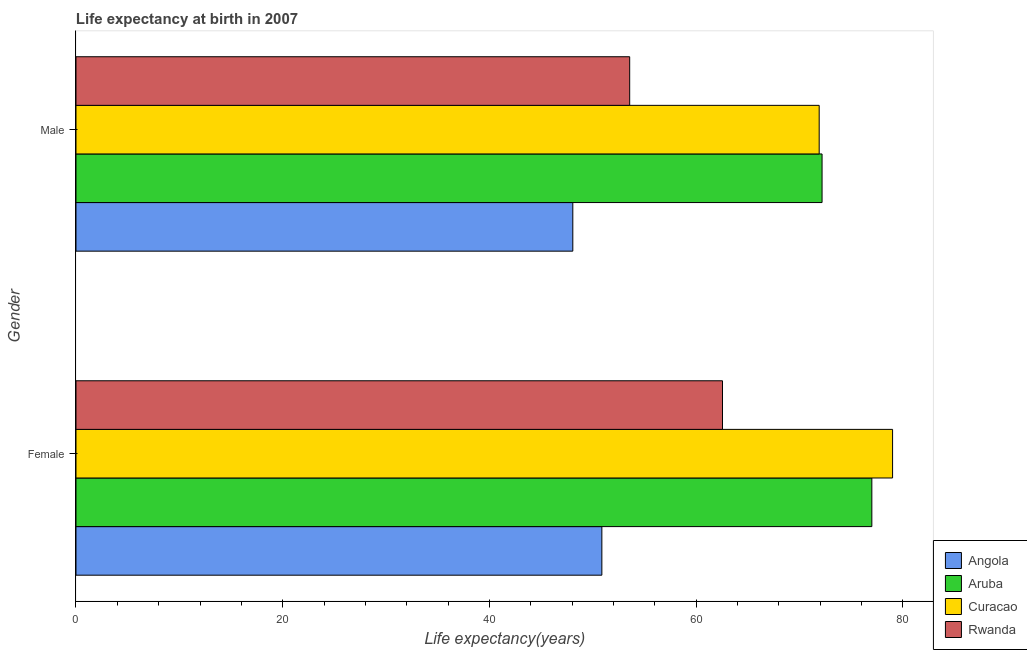How many different coloured bars are there?
Provide a succinct answer. 4. Are the number of bars on each tick of the Y-axis equal?
Your answer should be compact. Yes. How many bars are there on the 1st tick from the bottom?
Make the answer very short. 4. What is the life expectancy(male) in Angola?
Provide a short and direct response. 48.06. Across all countries, what is the maximum life expectancy(male)?
Your response must be concise. 72.18. Across all countries, what is the minimum life expectancy(female)?
Provide a short and direct response. 50.88. In which country was the life expectancy(male) maximum?
Offer a terse response. Aruba. In which country was the life expectancy(male) minimum?
Ensure brevity in your answer.  Angola. What is the total life expectancy(female) in the graph?
Keep it short and to the point. 269.41. What is the difference between the life expectancy(male) in Curacao and that in Rwanda?
Your response must be concise. 18.33. What is the difference between the life expectancy(female) in Curacao and the life expectancy(male) in Angola?
Provide a succinct answer. 30.94. What is the average life expectancy(male) per country?
Give a very brief answer. 61.43. What is the difference between the life expectancy(female) and life expectancy(male) in Angola?
Ensure brevity in your answer.  2.81. In how many countries, is the life expectancy(female) greater than 8 years?
Your response must be concise. 4. What is the ratio of the life expectancy(male) in Rwanda to that in Angola?
Offer a very short reply. 1.11. Is the life expectancy(male) in Angola less than that in Rwanda?
Keep it short and to the point. Yes. In how many countries, is the life expectancy(female) greater than the average life expectancy(female) taken over all countries?
Give a very brief answer. 2. What does the 3rd bar from the top in Female represents?
Ensure brevity in your answer.  Aruba. What does the 4th bar from the bottom in Female represents?
Your response must be concise. Rwanda. How many bars are there?
Keep it short and to the point. 8. How many countries are there in the graph?
Offer a very short reply. 4. What is the difference between two consecutive major ticks on the X-axis?
Provide a succinct answer. 20. Does the graph contain any zero values?
Offer a terse response. No. How are the legend labels stacked?
Your answer should be very brief. Vertical. What is the title of the graph?
Make the answer very short. Life expectancy at birth in 2007. Does "Iceland" appear as one of the legend labels in the graph?
Offer a terse response. No. What is the label or title of the X-axis?
Provide a succinct answer. Life expectancy(years). What is the label or title of the Y-axis?
Keep it short and to the point. Gender. What is the Life expectancy(years) of Angola in Female?
Your response must be concise. 50.88. What is the Life expectancy(years) in Aruba in Female?
Your answer should be very brief. 76.99. What is the Life expectancy(years) in Curacao in Female?
Provide a short and direct response. 79. What is the Life expectancy(years) in Rwanda in Female?
Ensure brevity in your answer.  62.55. What is the Life expectancy(years) in Angola in Male?
Offer a terse response. 48.06. What is the Life expectancy(years) of Aruba in Male?
Your response must be concise. 72.18. What is the Life expectancy(years) of Curacao in Male?
Your answer should be compact. 71.9. What is the Life expectancy(years) in Rwanda in Male?
Provide a succinct answer. 53.57. Across all Gender, what is the maximum Life expectancy(years) in Angola?
Make the answer very short. 50.88. Across all Gender, what is the maximum Life expectancy(years) of Aruba?
Provide a succinct answer. 76.99. Across all Gender, what is the maximum Life expectancy(years) of Curacao?
Provide a short and direct response. 79. Across all Gender, what is the maximum Life expectancy(years) of Rwanda?
Provide a succinct answer. 62.55. Across all Gender, what is the minimum Life expectancy(years) of Angola?
Make the answer very short. 48.06. Across all Gender, what is the minimum Life expectancy(years) of Aruba?
Keep it short and to the point. 72.18. Across all Gender, what is the minimum Life expectancy(years) of Curacao?
Give a very brief answer. 71.9. Across all Gender, what is the minimum Life expectancy(years) in Rwanda?
Provide a succinct answer. 53.57. What is the total Life expectancy(years) of Angola in the graph?
Keep it short and to the point. 98.94. What is the total Life expectancy(years) in Aruba in the graph?
Keep it short and to the point. 149.17. What is the total Life expectancy(years) in Curacao in the graph?
Your answer should be compact. 150.9. What is the total Life expectancy(years) in Rwanda in the graph?
Provide a short and direct response. 116.11. What is the difference between the Life expectancy(years) in Angola in Female and that in Male?
Provide a short and direct response. 2.81. What is the difference between the Life expectancy(years) in Aruba in Female and that in Male?
Keep it short and to the point. 4.82. What is the difference between the Life expectancy(years) of Curacao in Female and that in Male?
Keep it short and to the point. 7.1. What is the difference between the Life expectancy(years) in Rwanda in Female and that in Male?
Ensure brevity in your answer.  8.98. What is the difference between the Life expectancy(years) in Angola in Female and the Life expectancy(years) in Aruba in Male?
Give a very brief answer. -21.3. What is the difference between the Life expectancy(years) of Angola in Female and the Life expectancy(years) of Curacao in Male?
Provide a short and direct response. -21.02. What is the difference between the Life expectancy(years) in Angola in Female and the Life expectancy(years) in Rwanda in Male?
Your answer should be very brief. -2.69. What is the difference between the Life expectancy(years) in Aruba in Female and the Life expectancy(years) in Curacao in Male?
Give a very brief answer. 5.09. What is the difference between the Life expectancy(years) in Aruba in Female and the Life expectancy(years) in Rwanda in Male?
Offer a very short reply. 23.43. What is the difference between the Life expectancy(years) of Curacao in Female and the Life expectancy(years) of Rwanda in Male?
Offer a terse response. 25.43. What is the average Life expectancy(years) of Angola per Gender?
Make the answer very short. 49.47. What is the average Life expectancy(years) of Aruba per Gender?
Provide a short and direct response. 74.59. What is the average Life expectancy(years) of Curacao per Gender?
Give a very brief answer. 75.45. What is the average Life expectancy(years) of Rwanda per Gender?
Offer a terse response. 58.06. What is the difference between the Life expectancy(years) in Angola and Life expectancy(years) in Aruba in Female?
Make the answer very short. -26.12. What is the difference between the Life expectancy(years) of Angola and Life expectancy(years) of Curacao in Female?
Make the answer very short. -28.12. What is the difference between the Life expectancy(years) in Angola and Life expectancy(years) in Rwanda in Female?
Your response must be concise. -11.67. What is the difference between the Life expectancy(years) in Aruba and Life expectancy(years) in Curacao in Female?
Your answer should be compact. -2.01. What is the difference between the Life expectancy(years) in Aruba and Life expectancy(years) in Rwanda in Female?
Provide a succinct answer. 14.45. What is the difference between the Life expectancy(years) in Curacao and Life expectancy(years) in Rwanda in Female?
Your answer should be very brief. 16.45. What is the difference between the Life expectancy(years) of Angola and Life expectancy(years) of Aruba in Male?
Keep it short and to the point. -24.11. What is the difference between the Life expectancy(years) of Angola and Life expectancy(years) of Curacao in Male?
Your response must be concise. -23.84. What is the difference between the Life expectancy(years) in Angola and Life expectancy(years) in Rwanda in Male?
Ensure brevity in your answer.  -5.5. What is the difference between the Life expectancy(years) of Aruba and Life expectancy(years) of Curacao in Male?
Keep it short and to the point. 0.28. What is the difference between the Life expectancy(years) of Aruba and Life expectancy(years) of Rwanda in Male?
Ensure brevity in your answer.  18.61. What is the difference between the Life expectancy(years) in Curacao and Life expectancy(years) in Rwanda in Male?
Give a very brief answer. 18.33. What is the ratio of the Life expectancy(years) in Angola in Female to that in Male?
Make the answer very short. 1.06. What is the ratio of the Life expectancy(years) in Aruba in Female to that in Male?
Give a very brief answer. 1.07. What is the ratio of the Life expectancy(years) in Curacao in Female to that in Male?
Your response must be concise. 1.1. What is the ratio of the Life expectancy(years) in Rwanda in Female to that in Male?
Your answer should be very brief. 1.17. What is the difference between the highest and the second highest Life expectancy(years) of Angola?
Provide a succinct answer. 2.81. What is the difference between the highest and the second highest Life expectancy(years) of Aruba?
Provide a succinct answer. 4.82. What is the difference between the highest and the second highest Life expectancy(years) of Rwanda?
Your answer should be compact. 8.98. What is the difference between the highest and the lowest Life expectancy(years) in Angola?
Offer a very short reply. 2.81. What is the difference between the highest and the lowest Life expectancy(years) in Aruba?
Give a very brief answer. 4.82. What is the difference between the highest and the lowest Life expectancy(years) in Curacao?
Give a very brief answer. 7.1. What is the difference between the highest and the lowest Life expectancy(years) in Rwanda?
Your response must be concise. 8.98. 